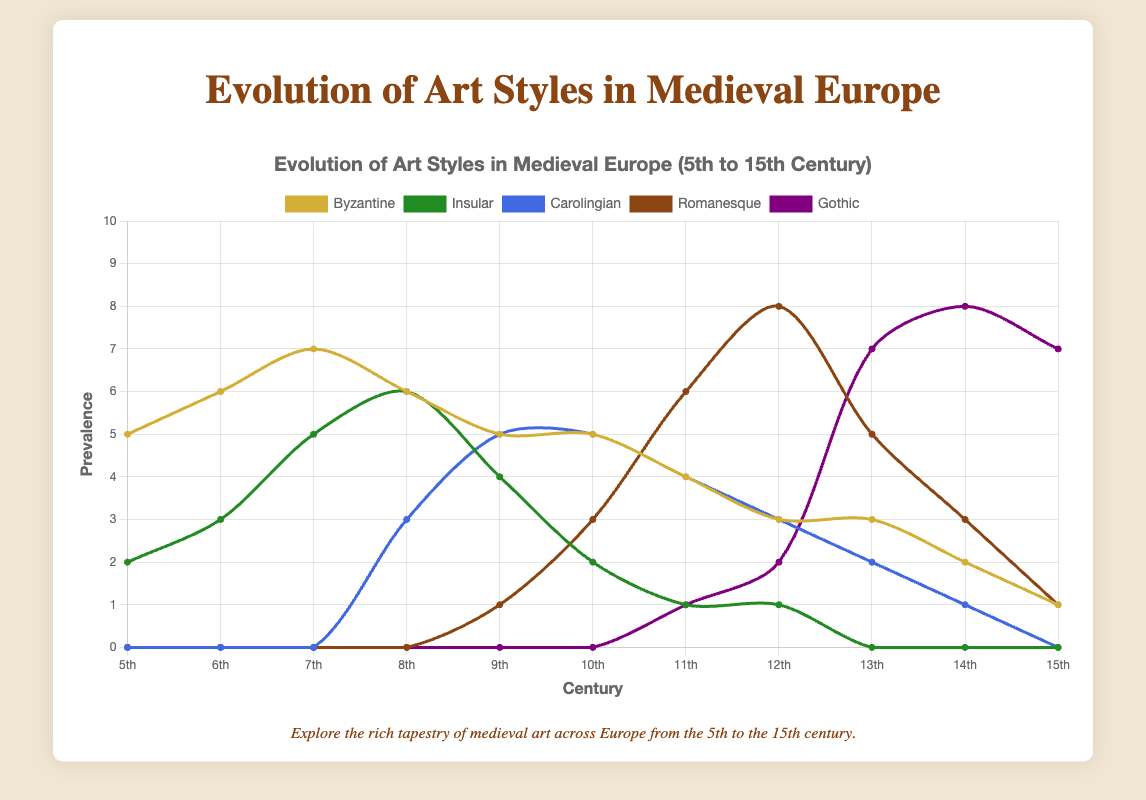Which art style had the greatest prevalence in the 7th century? The chart shows that the Byzantine style had a prevalence of 7 in the 7th century, which is the highest value among all art styles for that century.
Answer: Byzantine How does the prevalence of Gothic art in the 15th century compare to the 13th century? In the 15th century, Gothic art has a prevalence of 7, while in the 13th century it had a prevalence of 7 as well. Hence, the prevalence of Gothic art remains the same in the 15th century compared to the 13th century.
Answer: Equal Which art styles were present in all time periods from the 5th to the 15th century? By inspecting the chart, it is clear that only Byzantine art is consistently present across all centuries from the 5th to the 15th. Other art styles either start later or fade away earlier.
Answer: Byzantine Which two centuries saw the highest prevalence of Romanesque art, and what were the values? The chart reveals that the highest prevalence of Romanesque art occurred in the 12th century with a value of 8, and the second-highest occurred in the 11th century with a value of 6.
Answer: 12th (8), 11th (6) What is the sum of the prevalence values of Insular art in the 6th and 8th centuries? The chart shows Insular art has a prevalence of 3 in the 6th century and a prevalence of 6 in the 8th century. Summing these values gives 3 + 6 = 9.
Answer: 9 Between the 10th and 12th centuries, which art style had the most significant increase in prevalence and by how much? Comparing the values, Gothic art increased from 0 in the 10th century to 2 in the 12th century, showing an increase of 2. Romanesque art increased from 3 in the 10th century to 8 in the 12th century, showing an increase of 5. Thus, Romanesque had the most significant increase by 5.
Answer: Romanesque, 5 Is there any art style that completely vanished by the 15th century, and if so, which one? The chart indicates that Insular art, which has values from the 5th to the 12th century, completely disappears by the 15th century (value 0).
Answer: Insular What is the combined prevalence of Carolingian and Gothic art in the 14th century? According to the chart, Carolingian art has a value of 1 and Gothic art has a value of 8 in the 14th century. Summing these up gives 1 + 8 = 9.
Answer: 9 Which century marked the emergence of Carolingian art, and what was its initial prevalence value? By looking at the chart, we can see that Carolingian art first appeared in the 8th century with an initial prevalence value of 3.
Answer: 8th century, 3 